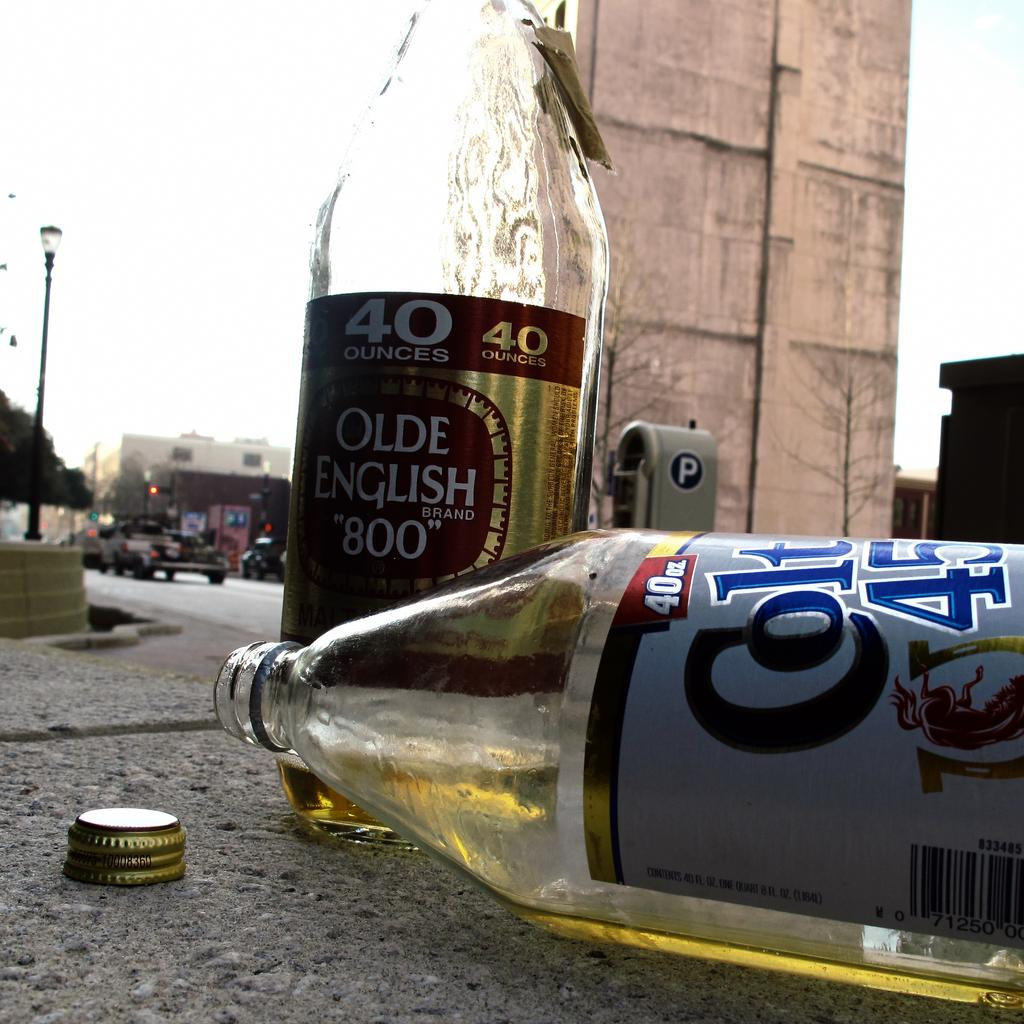Provide a one-sentence caption for the provided image. Two malt liquor bottles, Olde English 800 and Colt 45, lie on the pavement. 